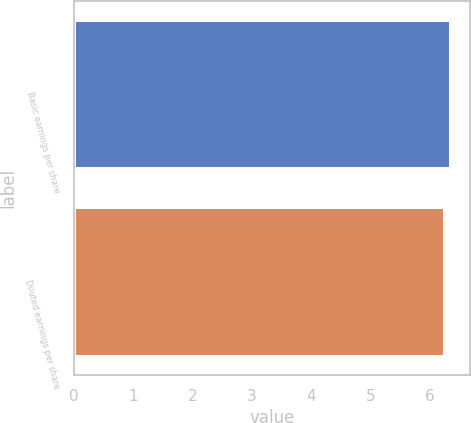Convert chart. <chart><loc_0><loc_0><loc_500><loc_500><bar_chart><fcel>Basic earnings per share<fcel>Diluted earnings per share<nl><fcel>6.36<fcel>6.25<nl></chart> 